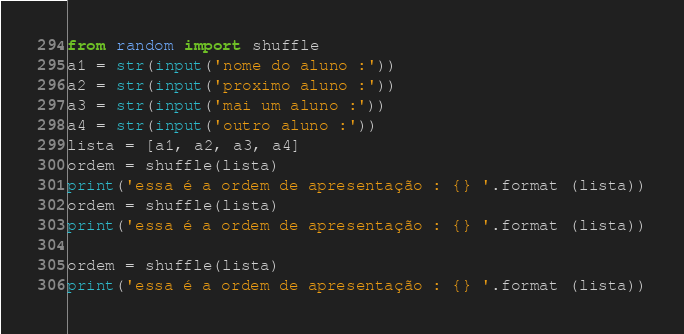<code> <loc_0><loc_0><loc_500><loc_500><_Python_>from random import shuffle
a1 = str(input('nome do aluno :'))
a2 = str(input('proximo aluno :'))
a3 = str(input('mai um aluno :'))
a4 = str(input('outro aluno :'))
lista = [a1, a2, a3, a4]
ordem = shuffle(lista)
print('essa é a ordem de apresentação : {} '.format (lista))
ordem = shuffle(lista)
print('essa é a ordem de apresentação : {} '.format (lista))

ordem = shuffle(lista)
print('essa é a ordem de apresentação : {} '.format (lista))

</code> 